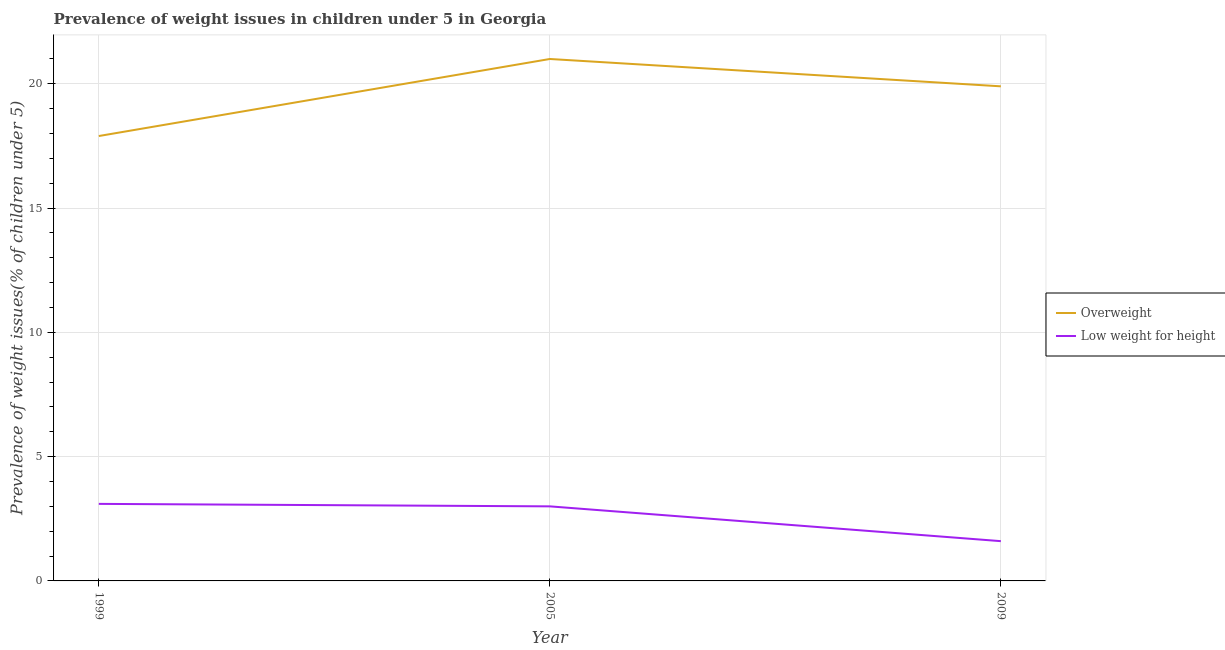How many different coloured lines are there?
Make the answer very short. 2. Does the line corresponding to percentage of overweight children intersect with the line corresponding to percentage of underweight children?
Your answer should be very brief. No. Is the number of lines equal to the number of legend labels?
Your response must be concise. Yes. What is the percentage of underweight children in 2005?
Offer a very short reply. 3. Across all years, what is the maximum percentage of overweight children?
Give a very brief answer. 21. Across all years, what is the minimum percentage of overweight children?
Give a very brief answer. 17.9. What is the total percentage of overweight children in the graph?
Keep it short and to the point. 58.8. What is the difference between the percentage of underweight children in 1999 and that in 2009?
Your response must be concise. 1.5. What is the difference between the percentage of underweight children in 1999 and the percentage of overweight children in 2005?
Your response must be concise. -17.9. What is the average percentage of underweight children per year?
Your answer should be very brief. 2.57. In the year 2009, what is the difference between the percentage of underweight children and percentage of overweight children?
Give a very brief answer. -18.3. What is the ratio of the percentage of overweight children in 1999 to that in 2009?
Give a very brief answer. 0.9. Is the percentage of underweight children in 1999 less than that in 2005?
Provide a short and direct response. No. What is the difference between the highest and the second highest percentage of underweight children?
Your response must be concise. 0.1. What is the difference between the highest and the lowest percentage of underweight children?
Offer a very short reply. 1.5. In how many years, is the percentage of overweight children greater than the average percentage of overweight children taken over all years?
Your answer should be compact. 2. Does the percentage of overweight children monotonically increase over the years?
Your response must be concise. No. Is the percentage of overweight children strictly greater than the percentage of underweight children over the years?
Keep it short and to the point. Yes. Is the percentage of overweight children strictly less than the percentage of underweight children over the years?
Offer a terse response. No. How many lines are there?
Provide a succinct answer. 2. Does the graph contain grids?
Offer a very short reply. Yes. Where does the legend appear in the graph?
Your answer should be very brief. Center right. How many legend labels are there?
Make the answer very short. 2. What is the title of the graph?
Your answer should be compact. Prevalence of weight issues in children under 5 in Georgia. Does "Number of arrivals" appear as one of the legend labels in the graph?
Provide a succinct answer. No. What is the label or title of the Y-axis?
Offer a terse response. Prevalence of weight issues(% of children under 5). What is the Prevalence of weight issues(% of children under 5) of Overweight in 1999?
Your response must be concise. 17.9. What is the Prevalence of weight issues(% of children under 5) in Low weight for height in 1999?
Your answer should be very brief. 3.1. What is the Prevalence of weight issues(% of children under 5) of Overweight in 2009?
Give a very brief answer. 19.9. What is the Prevalence of weight issues(% of children under 5) in Low weight for height in 2009?
Offer a very short reply. 1.6. Across all years, what is the maximum Prevalence of weight issues(% of children under 5) of Low weight for height?
Make the answer very short. 3.1. Across all years, what is the minimum Prevalence of weight issues(% of children under 5) in Overweight?
Your response must be concise. 17.9. Across all years, what is the minimum Prevalence of weight issues(% of children under 5) in Low weight for height?
Your response must be concise. 1.6. What is the total Prevalence of weight issues(% of children under 5) in Overweight in the graph?
Offer a very short reply. 58.8. What is the difference between the Prevalence of weight issues(% of children under 5) of Low weight for height in 1999 and that in 2009?
Provide a short and direct response. 1.5. What is the difference between the Prevalence of weight issues(% of children under 5) in Overweight in 1999 and the Prevalence of weight issues(% of children under 5) in Low weight for height in 2009?
Give a very brief answer. 16.3. What is the difference between the Prevalence of weight issues(% of children under 5) of Overweight in 2005 and the Prevalence of weight issues(% of children under 5) of Low weight for height in 2009?
Give a very brief answer. 19.4. What is the average Prevalence of weight issues(% of children under 5) of Overweight per year?
Provide a succinct answer. 19.6. What is the average Prevalence of weight issues(% of children under 5) in Low weight for height per year?
Offer a terse response. 2.57. In the year 1999, what is the difference between the Prevalence of weight issues(% of children under 5) of Overweight and Prevalence of weight issues(% of children under 5) of Low weight for height?
Provide a short and direct response. 14.8. In the year 2009, what is the difference between the Prevalence of weight issues(% of children under 5) of Overweight and Prevalence of weight issues(% of children under 5) of Low weight for height?
Your answer should be very brief. 18.3. What is the ratio of the Prevalence of weight issues(% of children under 5) of Overweight in 1999 to that in 2005?
Your answer should be very brief. 0.85. What is the ratio of the Prevalence of weight issues(% of children under 5) in Low weight for height in 1999 to that in 2005?
Your answer should be compact. 1.03. What is the ratio of the Prevalence of weight issues(% of children under 5) in Overweight in 1999 to that in 2009?
Ensure brevity in your answer.  0.9. What is the ratio of the Prevalence of weight issues(% of children under 5) in Low weight for height in 1999 to that in 2009?
Your answer should be compact. 1.94. What is the ratio of the Prevalence of weight issues(% of children under 5) in Overweight in 2005 to that in 2009?
Make the answer very short. 1.06. What is the ratio of the Prevalence of weight issues(% of children under 5) of Low weight for height in 2005 to that in 2009?
Ensure brevity in your answer.  1.88. 